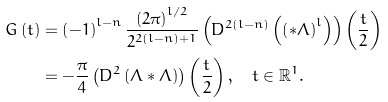<formula> <loc_0><loc_0><loc_500><loc_500>G \left ( t \right ) & = \left ( - 1 \right ) ^ { l - n } \frac { \left ( 2 \pi \right ) ^ { l / 2 } } { 2 ^ { 2 \left ( l - n \right ) + 1 } } \left ( D ^ { 2 \left ( l - n \right ) } \left ( \left ( \ast \Lambda \right ) ^ { l } \right ) \right ) \left ( \frac { t } { 2 } \right ) \\ & = - \frac { \pi } { 4 } \left ( D ^ { 2 } \left ( \Lambda \ast \Lambda \right ) \right ) \left ( \frac { t } { 2 } \right ) , \text {\quad} t \in \mathbb { R } ^ { 1 } .</formula> 